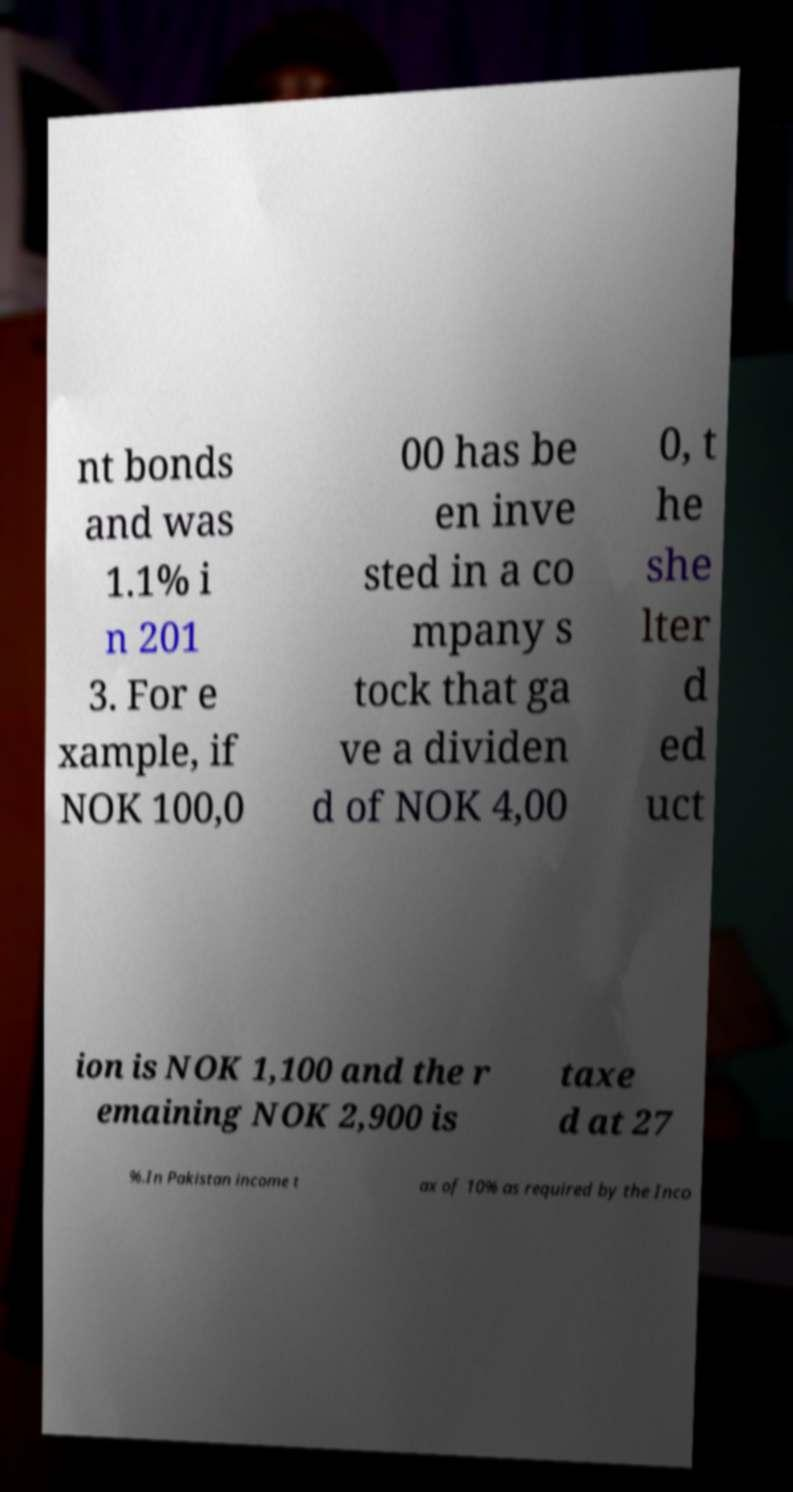Could you assist in decoding the text presented in this image and type it out clearly? nt bonds and was 1.1% i n 201 3. For e xample, if NOK 100,0 00 has be en inve sted in a co mpany s tock that ga ve a dividen d of NOK 4,00 0, t he she lter d ed uct ion is NOK 1,100 and the r emaining NOK 2,900 is taxe d at 27 %.In Pakistan income t ax of 10% as required by the Inco 